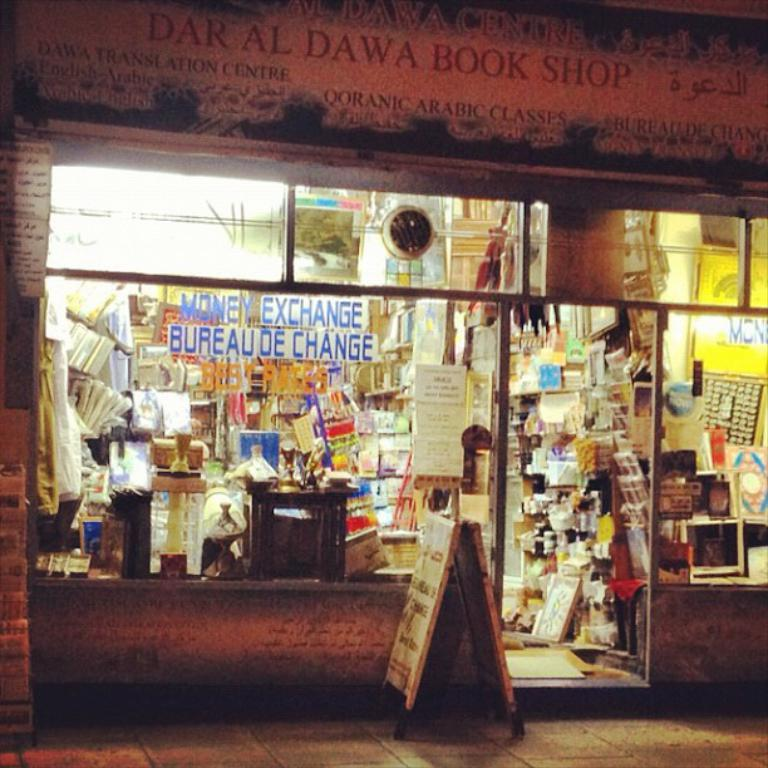<image>
Render a clear and concise summary of the photo. A store front that is called Dar Al DAwa Book Shop. 